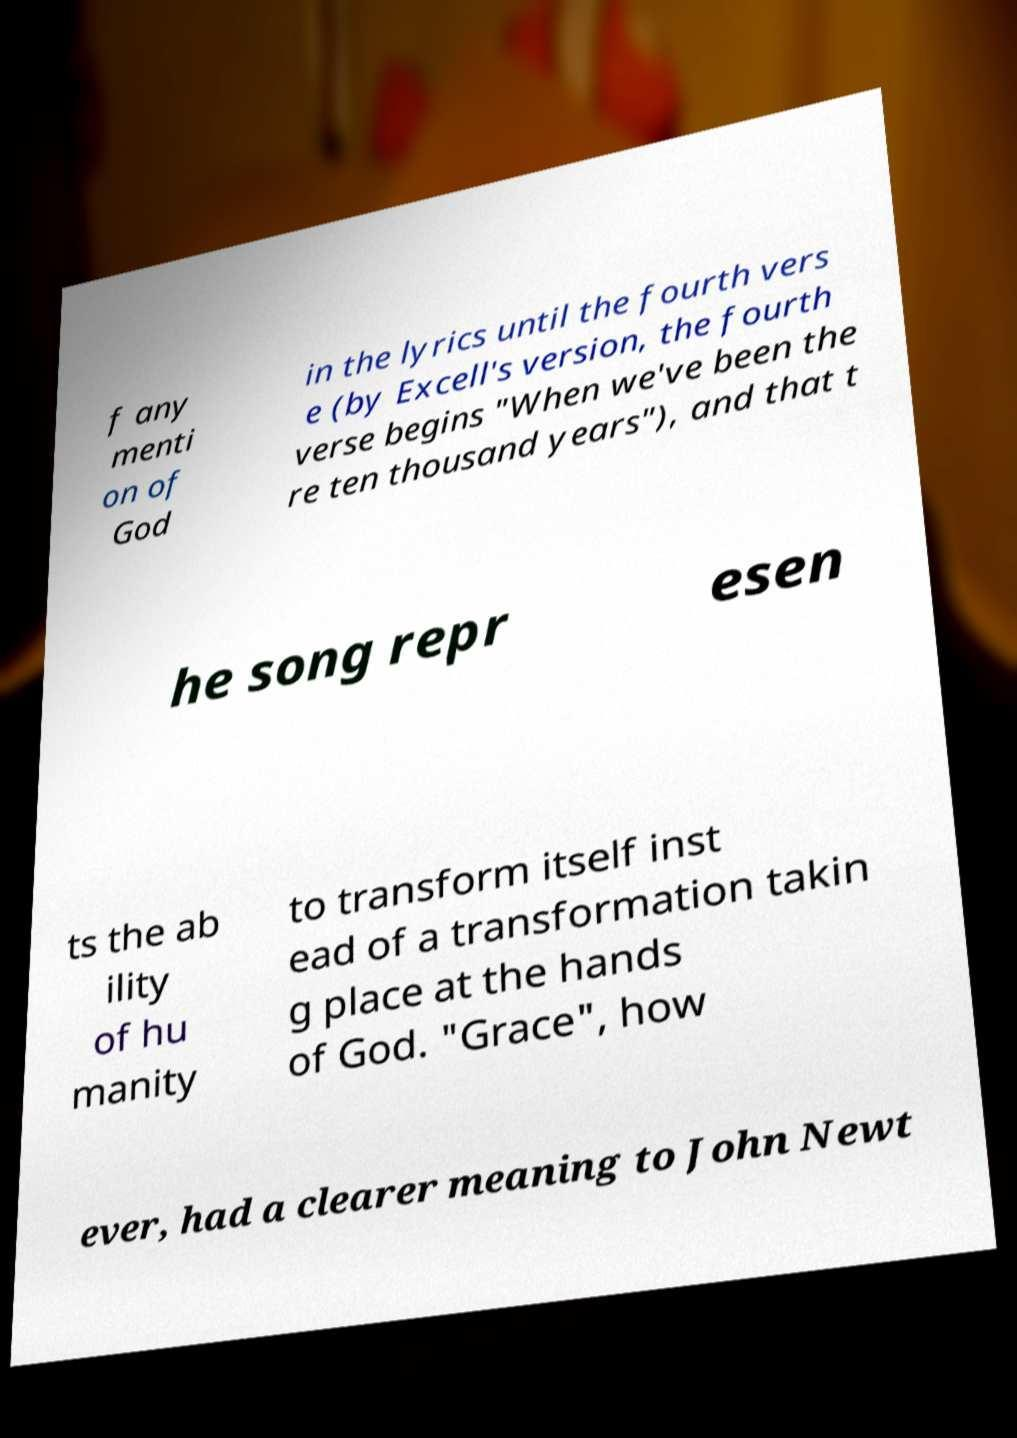Can you accurately transcribe the text from the provided image for me? f any menti on of God in the lyrics until the fourth vers e (by Excell's version, the fourth verse begins "When we've been the re ten thousand years"), and that t he song repr esen ts the ab ility of hu manity to transform itself inst ead of a transformation takin g place at the hands of God. "Grace", how ever, had a clearer meaning to John Newt 